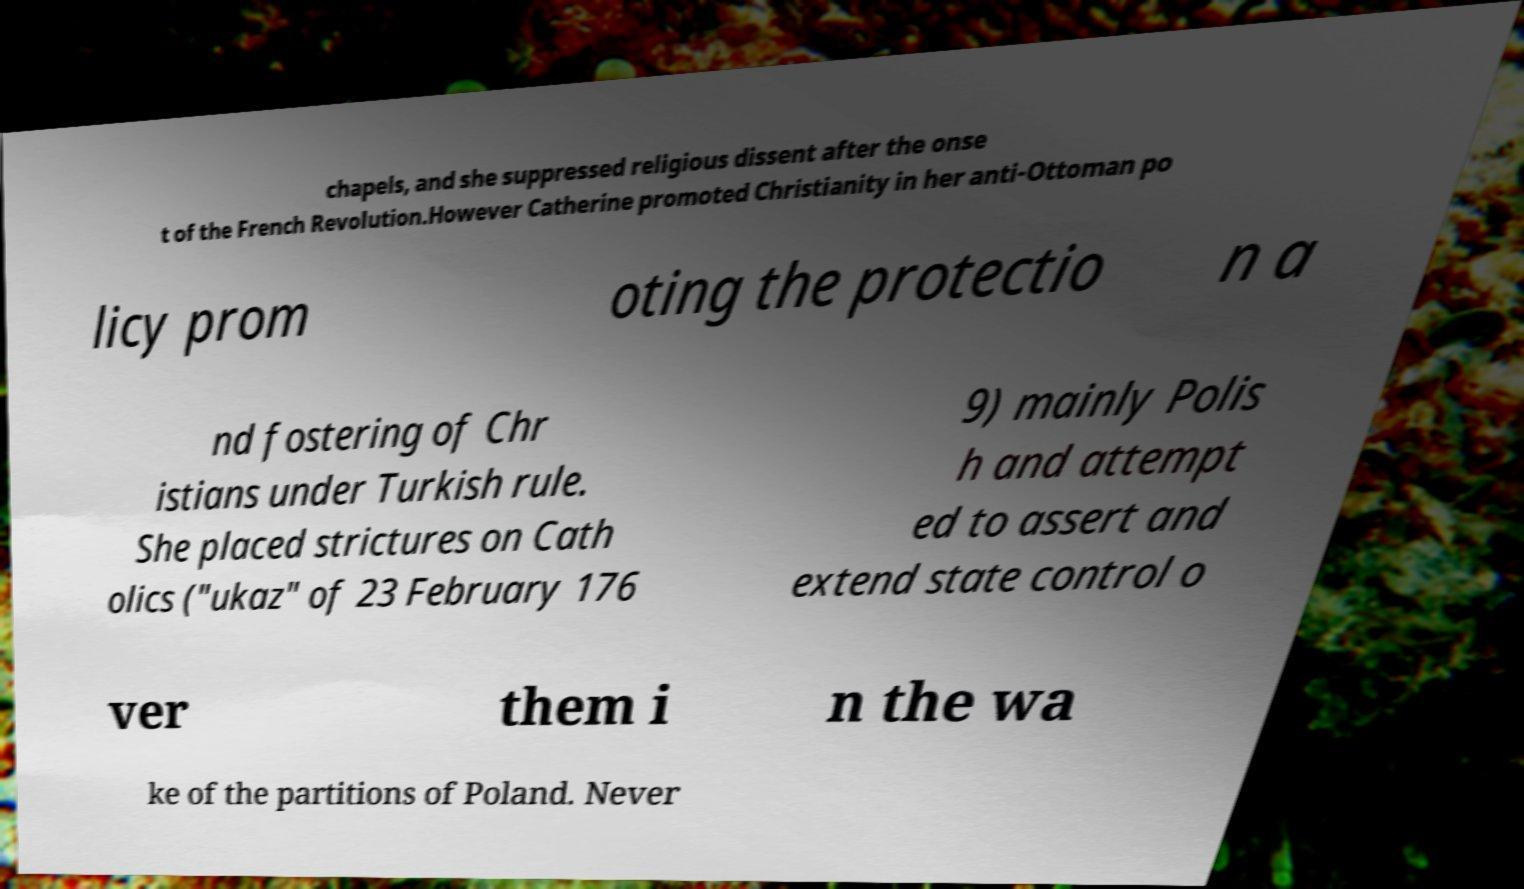Please read and relay the text visible in this image. What does it say? chapels, and she suppressed religious dissent after the onse t of the French Revolution.However Catherine promoted Christianity in her anti-Ottoman po licy prom oting the protectio n a nd fostering of Chr istians under Turkish rule. She placed strictures on Cath olics ("ukaz" of 23 February 176 9) mainly Polis h and attempt ed to assert and extend state control o ver them i n the wa ke of the partitions of Poland. Never 